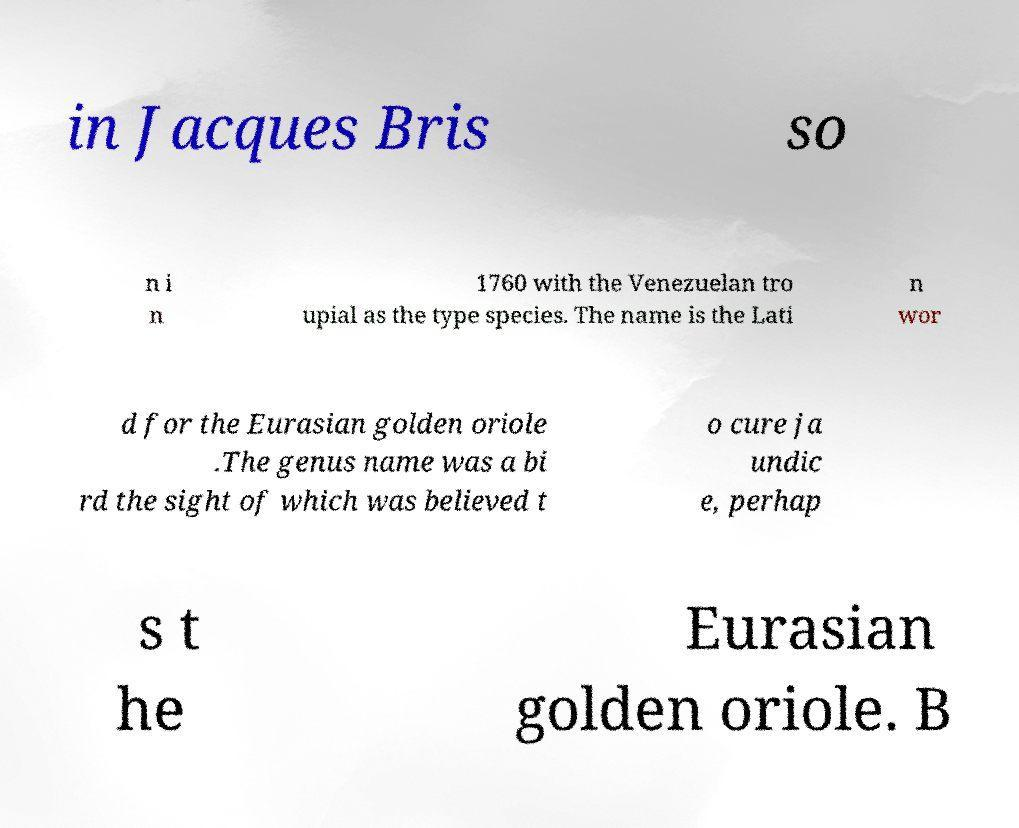For documentation purposes, I need the text within this image transcribed. Could you provide that? in Jacques Bris so n i n 1760 with the Venezuelan tro upial as the type species. The name is the Lati n wor d for the Eurasian golden oriole .The genus name was a bi rd the sight of which was believed t o cure ja undic e, perhap s t he Eurasian golden oriole. B 